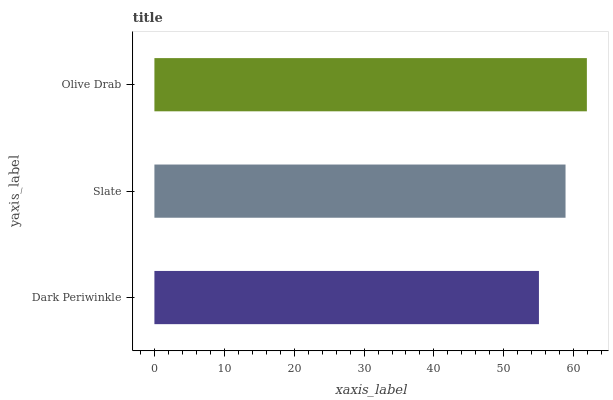Is Dark Periwinkle the minimum?
Answer yes or no. Yes. Is Olive Drab the maximum?
Answer yes or no. Yes. Is Slate the minimum?
Answer yes or no. No. Is Slate the maximum?
Answer yes or no. No. Is Slate greater than Dark Periwinkle?
Answer yes or no. Yes. Is Dark Periwinkle less than Slate?
Answer yes or no. Yes. Is Dark Periwinkle greater than Slate?
Answer yes or no. No. Is Slate less than Dark Periwinkle?
Answer yes or no. No. Is Slate the high median?
Answer yes or no. Yes. Is Slate the low median?
Answer yes or no. Yes. Is Dark Periwinkle the high median?
Answer yes or no. No. Is Dark Periwinkle the low median?
Answer yes or no. No. 